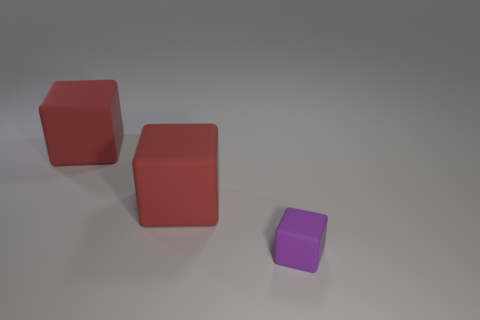If we were to use these blocks to teach children, what could they learn from them? These blocks are great educational tools. Children could learn about colors, sizes, counting, and spatial concepts such as 'behind,' 'left of,' and 'in front of.' Moreover, they could be employed to encourage sorting and categorizing skills. 